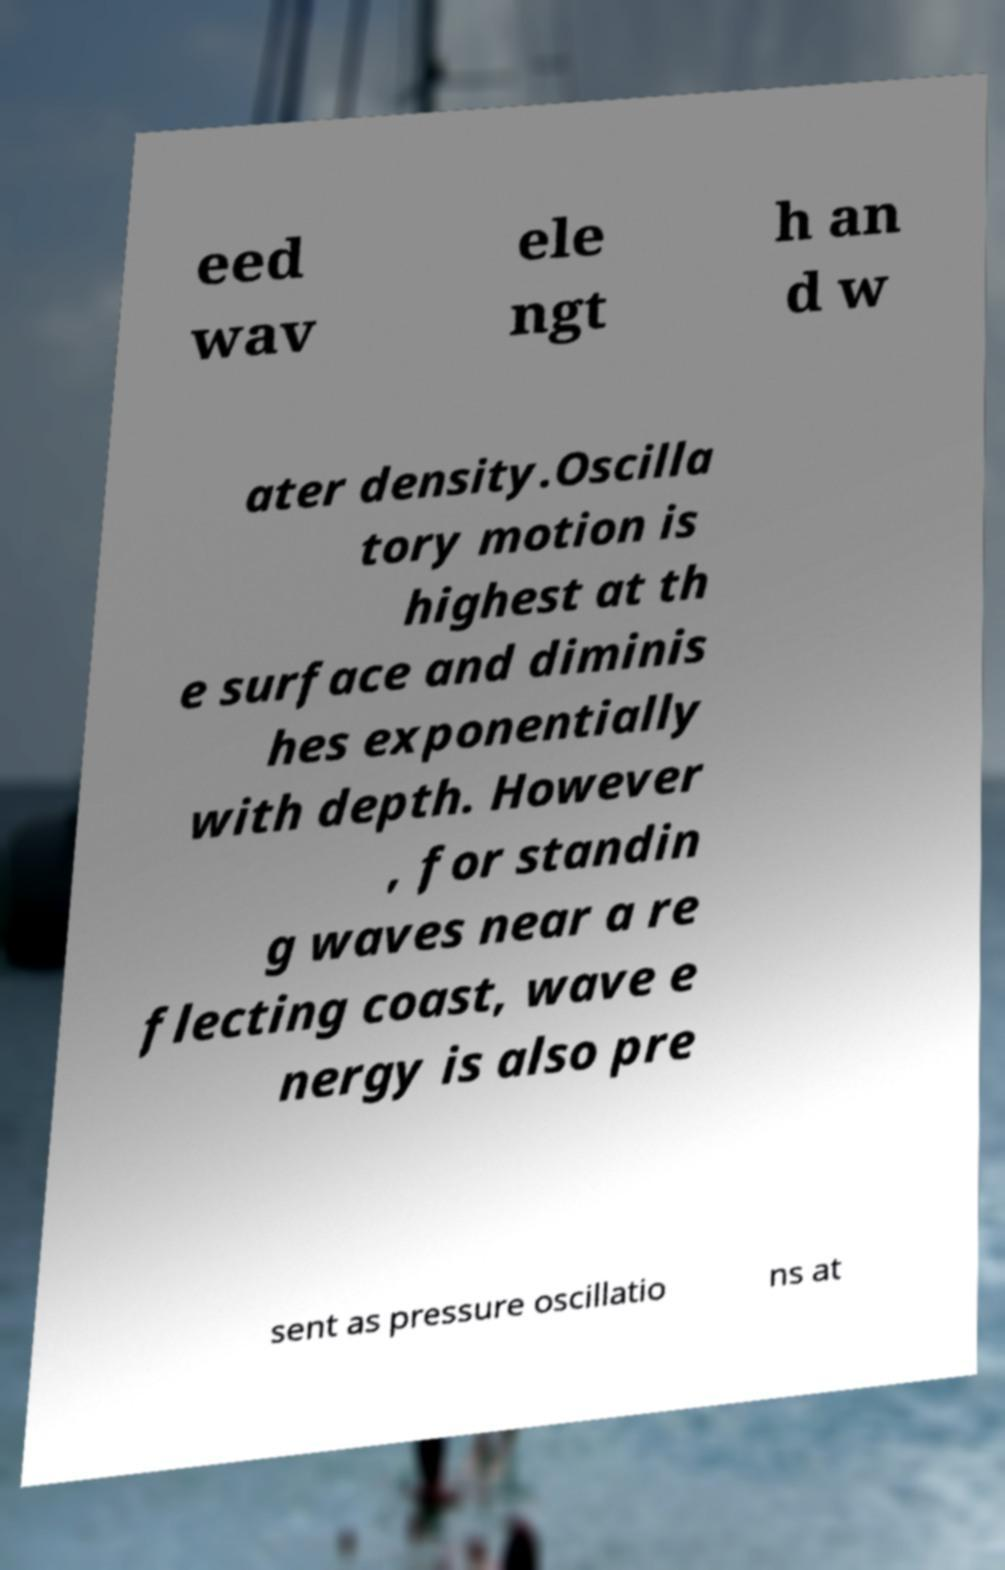Can you read and provide the text displayed in the image?This photo seems to have some interesting text. Can you extract and type it out for me? eed wav ele ngt h an d w ater density.Oscilla tory motion is highest at th e surface and diminis hes exponentially with depth. However , for standin g waves near a re flecting coast, wave e nergy is also pre sent as pressure oscillatio ns at 